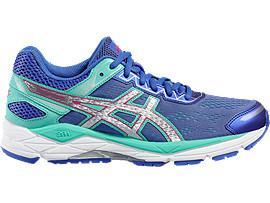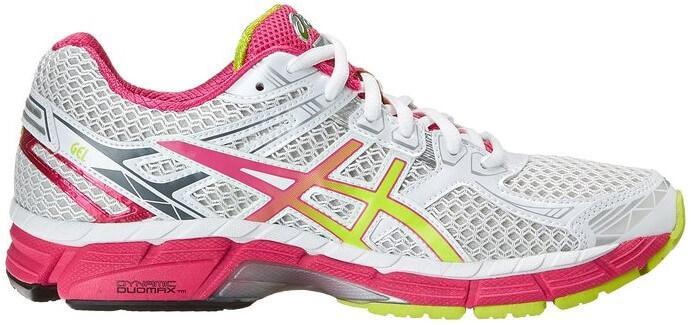The first image is the image on the left, the second image is the image on the right. Assess this claim about the two images: "Left and right images each contain a single sneaker, and the pair of images are arranged heel to heel.". Correct or not? Answer yes or no. No. The first image is the image on the left, the second image is the image on the right. For the images displayed, is the sentence "Both shoes have pink shoelaces." factually correct? Answer yes or no. No. 